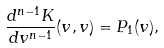Convert formula to latex. <formula><loc_0><loc_0><loc_500><loc_500>\frac { d ^ { n - 1 } K } { d v ^ { n - 1 } } ( v , v ) = P _ { 1 } ( v ) ,</formula> 